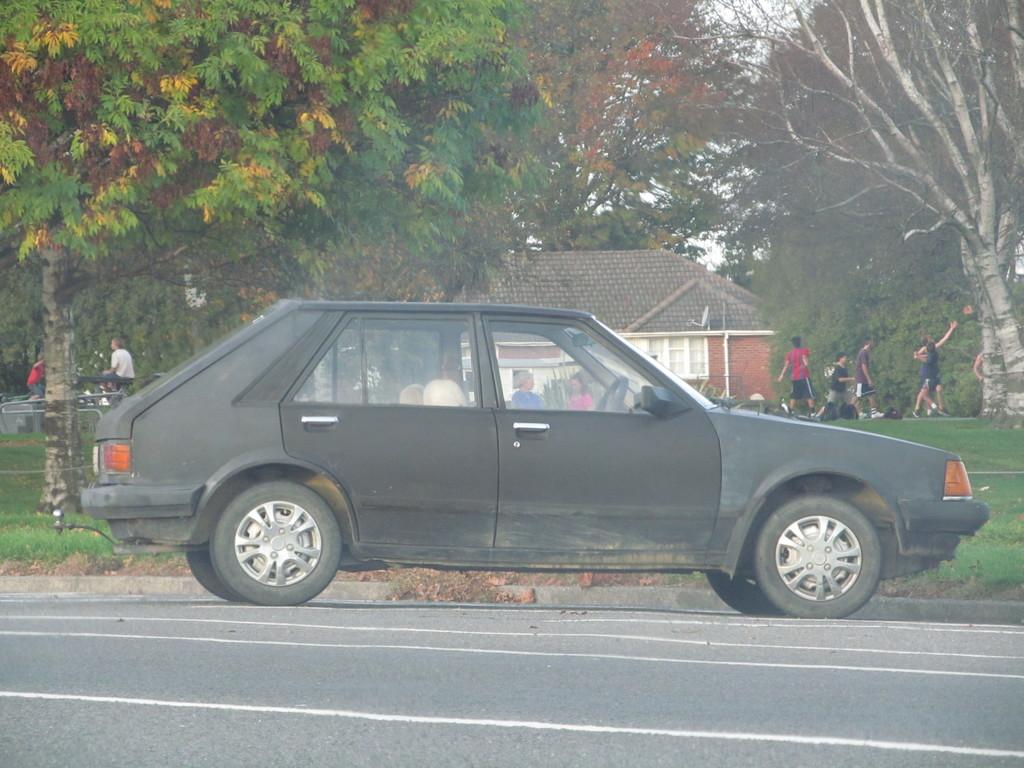What is the main subject of the image? The main subject of the image is a car on the road. What are the people in the image doing? The people in the image are on the grass. What type of structure is visible in the image? There is a house in the image. What else can be seen in the image besides the car, people, and house? There are objects visible in the image. What is visible in the background of the image? There are trees in the background of the image. What is the current temperature in the image? The image does not provide information about the temperature, so it cannot be determined. What date is shown on the calendar in the image? There is no calendar present in the image, so the date cannot be determined. 